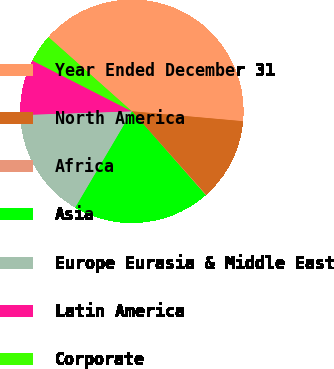Convert chart. <chart><loc_0><loc_0><loc_500><loc_500><pie_chart><fcel>Year Ended December 31<fcel>North America<fcel>Africa<fcel>Asia<fcel>Europe Eurasia & Middle East<fcel>Latin America<fcel>Corporate<nl><fcel>39.85%<fcel>12.01%<fcel>0.08%<fcel>19.97%<fcel>15.99%<fcel>8.04%<fcel>4.06%<nl></chart> 